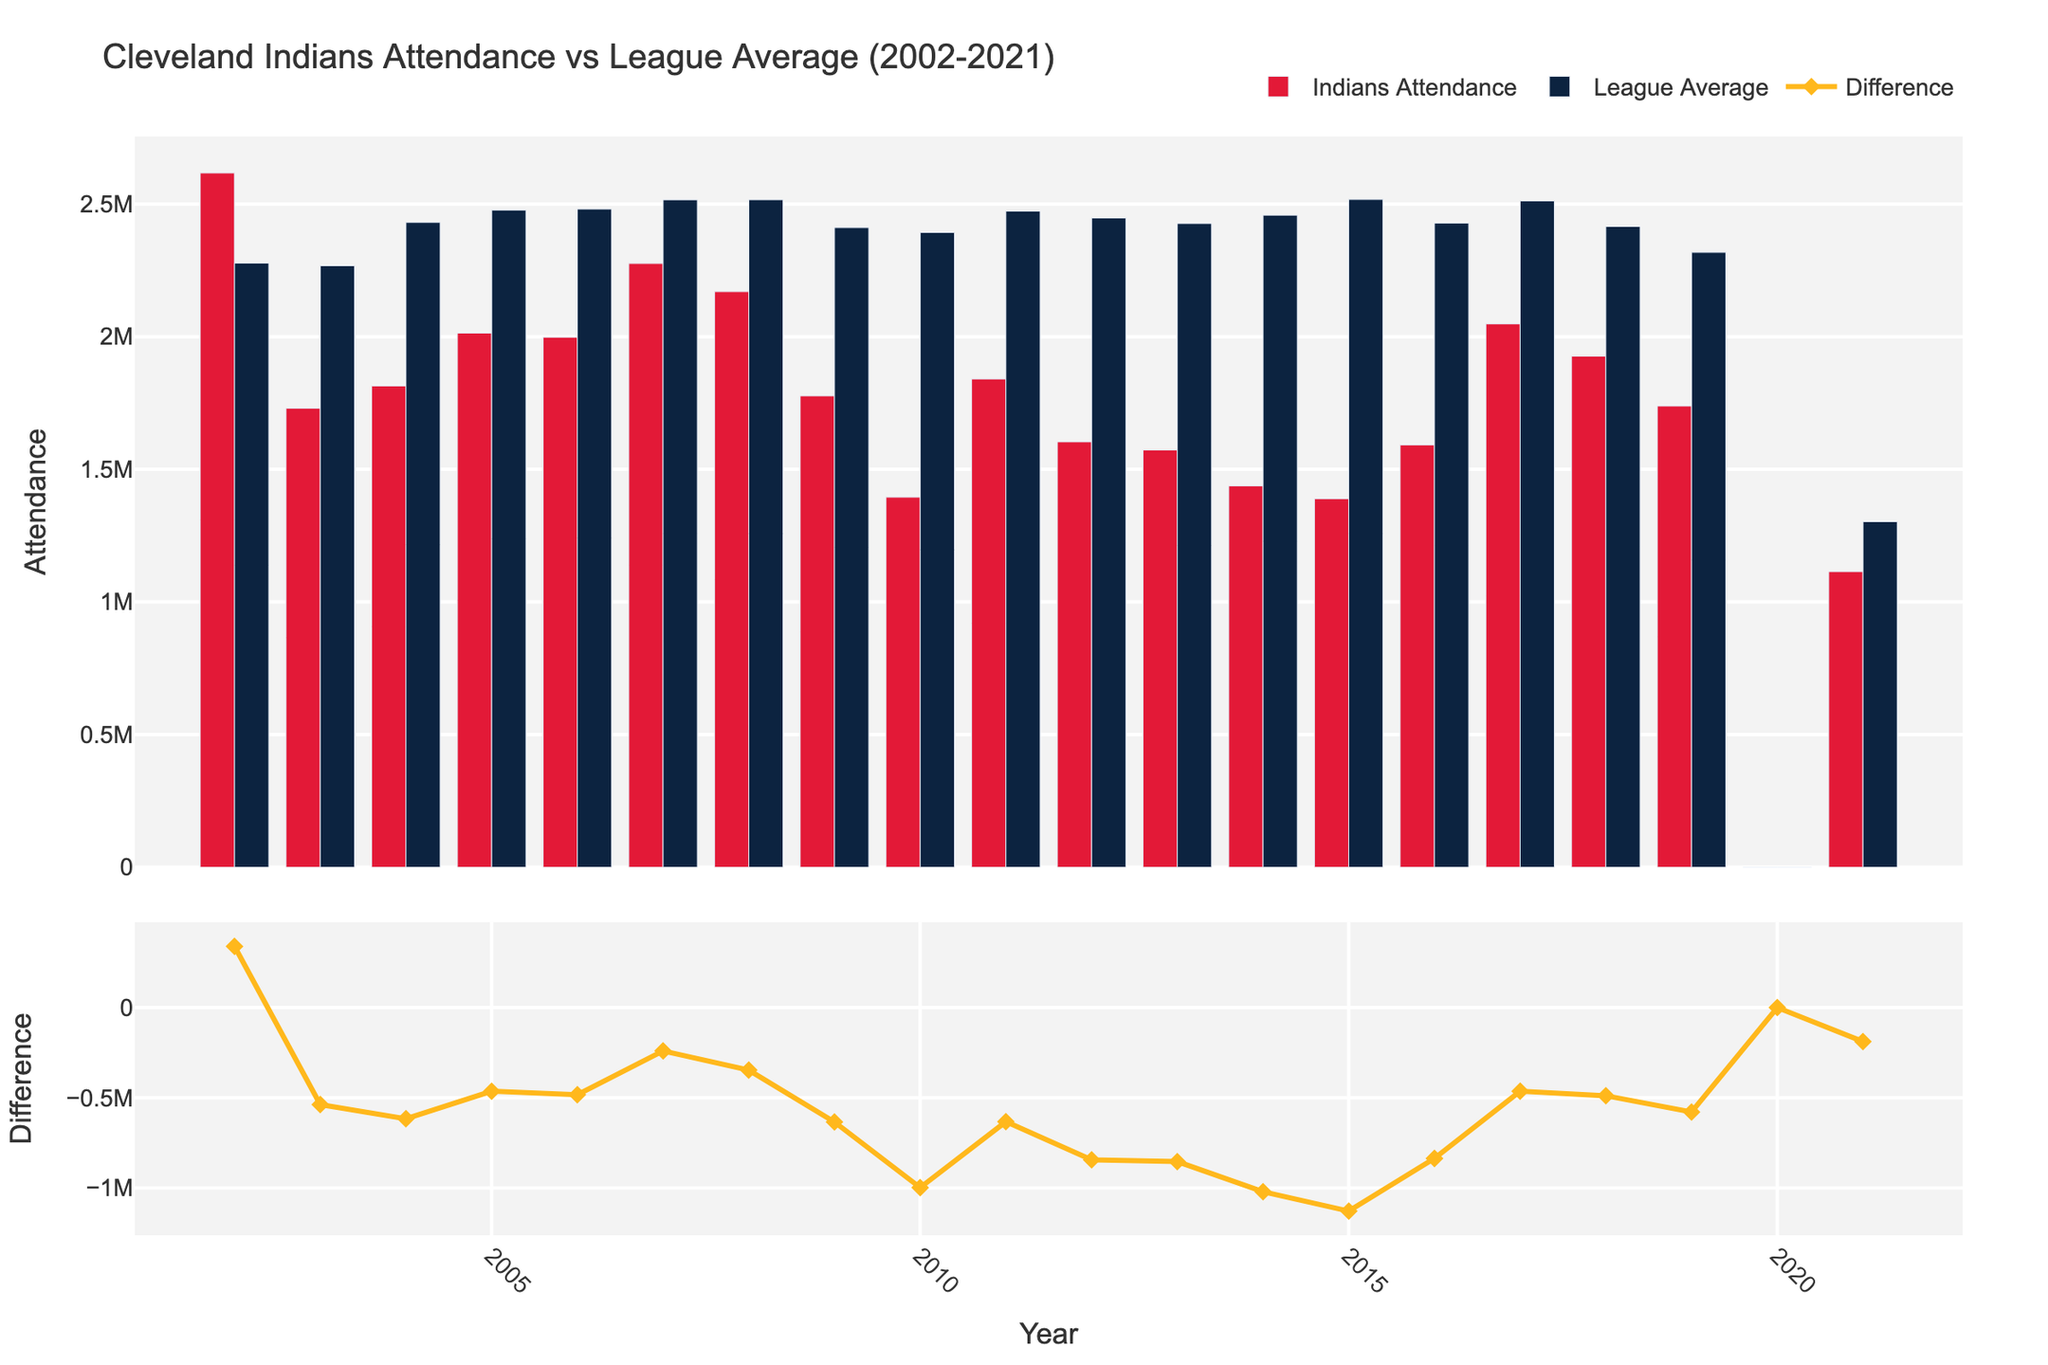What's the first year when the Cleveland Indians' attendance is significantly lower than the league average? The first noticeable drop is in 2003, where Indians' attendance (1,730,002) is substantially lower than the league average (2,267,361). The difference is -537,359.
Answer: 2003 In which year did the Cleveland Indians have the highest attendance relative to the league average? The highest relative attendance occurs in 2002 with Indian's attendance (2,616,940) surpassing the league average (2,277,521) by 339,419.
Answer: 2002 What was the difference in attendance between the Cleveland Indians and the league average in 2015? Looking at the 2015 data, Indians' attendance is 1,388,905 while the league average is 2,517,350, resulting in -1,128,445 difference.
Answer: -1,128,445 From 2016 to 2017, did the difference in attendance between the Cleveland Indians and the league average increase or decrease? In 2016, the difference was -836,324. In 2017, it was -463,510. The difference decreased by (-836,324) - (-463,510) = 372,814.
Answer: Decrease What was the total attendance for the Cleveland Indians across all the years except 2020? Adding the attendance from 2002-2021 excluding 2020: 26,169,940 + 1,730,002 + 1,814,401 + 2,013,763 + 1,997,995 + 2,275,916 + 2,169,760 + 1,776,904 + 1,394,812 + 1,840,835 + 1,603,596 + 1,572,926 + 1,437,393 + 1,388,905 + 1,591,667 + 2,048,138 + 1,926,701 + 1,738,642 + 1,114,368 = 33,916,766.
Answer: 33,916,766 Which year recorded the largest negative difference in attendance between the Cleveland Indians and the league average? In 2015, the difference was -1,128,445, which is the largest negative difference over the years.
Answer: 2015 During the period from 2002 to 2021, what is the median attendance for the Cleveland Indians? The sorted attendance values excluding 2020: 1114368, 1388905, 1394812, 1437393, 1572926, 1591667, 1603596, 1730002, 1738642, 1776904, 1814401, 1840835, 1926701, 1997995, 2013763, 2048138, 2169760, 2275916, 2616940. The 10th value in this sequence is 1,774,904 (1776904).
Answer: 1,774,904 For the year 2021, how much lower was the league average attendance compared to the previous year (2019)? The league average for 2019 was 2,317,830, whereas for 2021 it was 1,302,650. The difference is 2,317,830 - 1,302,650 = 1,015,180.
Answer: 1,015,180 